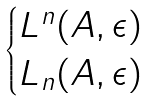<formula> <loc_0><loc_0><loc_500><loc_500>\begin{cases} L ^ { n } ( A , \epsilon ) \\ L _ { n } ( A , \epsilon ) \end{cases}</formula> 